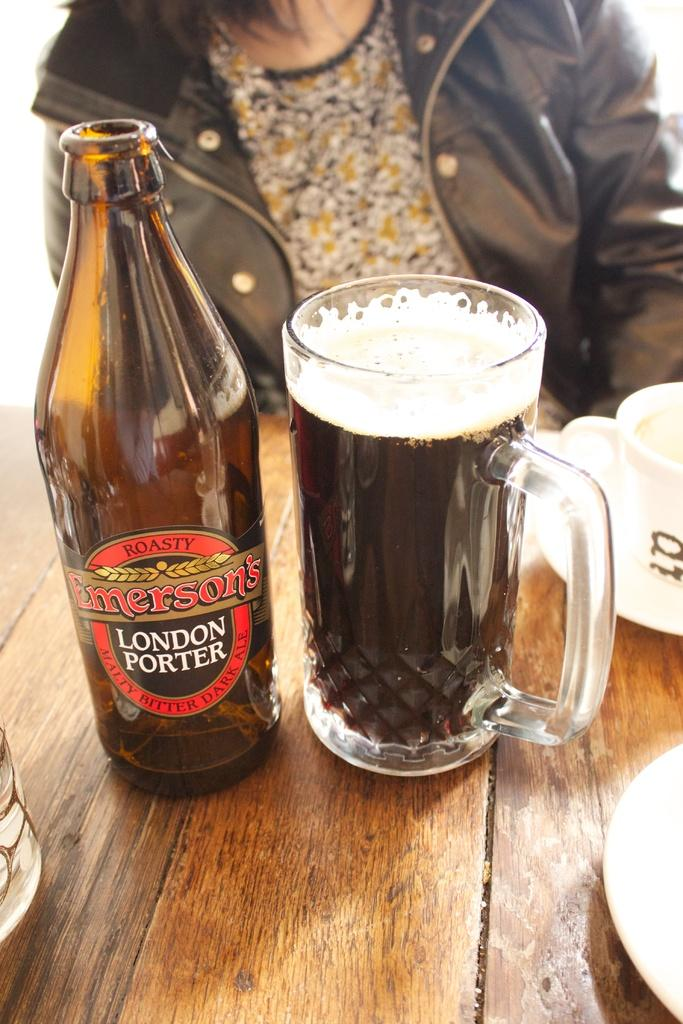<image>
Present a compact description of the photo's key features. An empty bottle of Emerson's London Porter sits next to a mug into which the beer has been poured. 